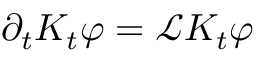Convert formula to latex. <formula><loc_0><loc_0><loc_500><loc_500>\partial _ { t } K _ { t } \varphi = \mathcal { L } K _ { t } \varphi</formula> 